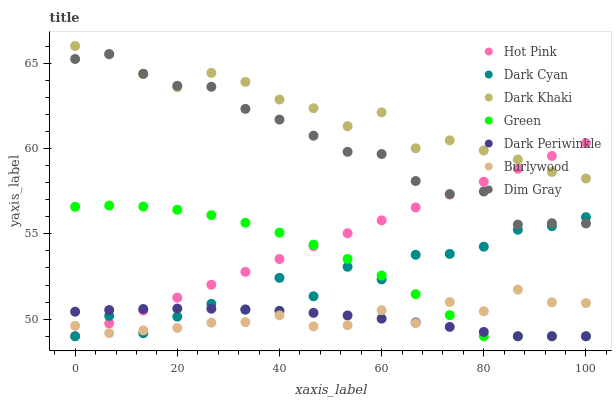Does Dark Periwinkle have the minimum area under the curve?
Answer yes or no. Yes. Does Dark Khaki have the maximum area under the curve?
Answer yes or no. Yes. Does Burlywood have the minimum area under the curve?
Answer yes or no. No. Does Burlywood have the maximum area under the curve?
Answer yes or no. No. Is Hot Pink the smoothest?
Answer yes or no. Yes. Is Dark Cyan the roughest?
Answer yes or no. Yes. Is Burlywood the smoothest?
Answer yes or no. No. Is Burlywood the roughest?
Answer yes or no. No. Does Hot Pink have the lowest value?
Answer yes or no. Yes. Does Burlywood have the lowest value?
Answer yes or no. No. Does Dark Khaki have the highest value?
Answer yes or no. Yes. Does Burlywood have the highest value?
Answer yes or no. No. Is Dark Cyan less than Dark Khaki?
Answer yes or no. Yes. Is Dark Khaki greater than Burlywood?
Answer yes or no. Yes. Does Burlywood intersect Green?
Answer yes or no. Yes. Is Burlywood less than Green?
Answer yes or no. No. Is Burlywood greater than Green?
Answer yes or no. No. Does Dark Cyan intersect Dark Khaki?
Answer yes or no. No. 